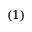<formula> <loc_0><loc_0><loc_500><loc_500>( 1 )</formula> 